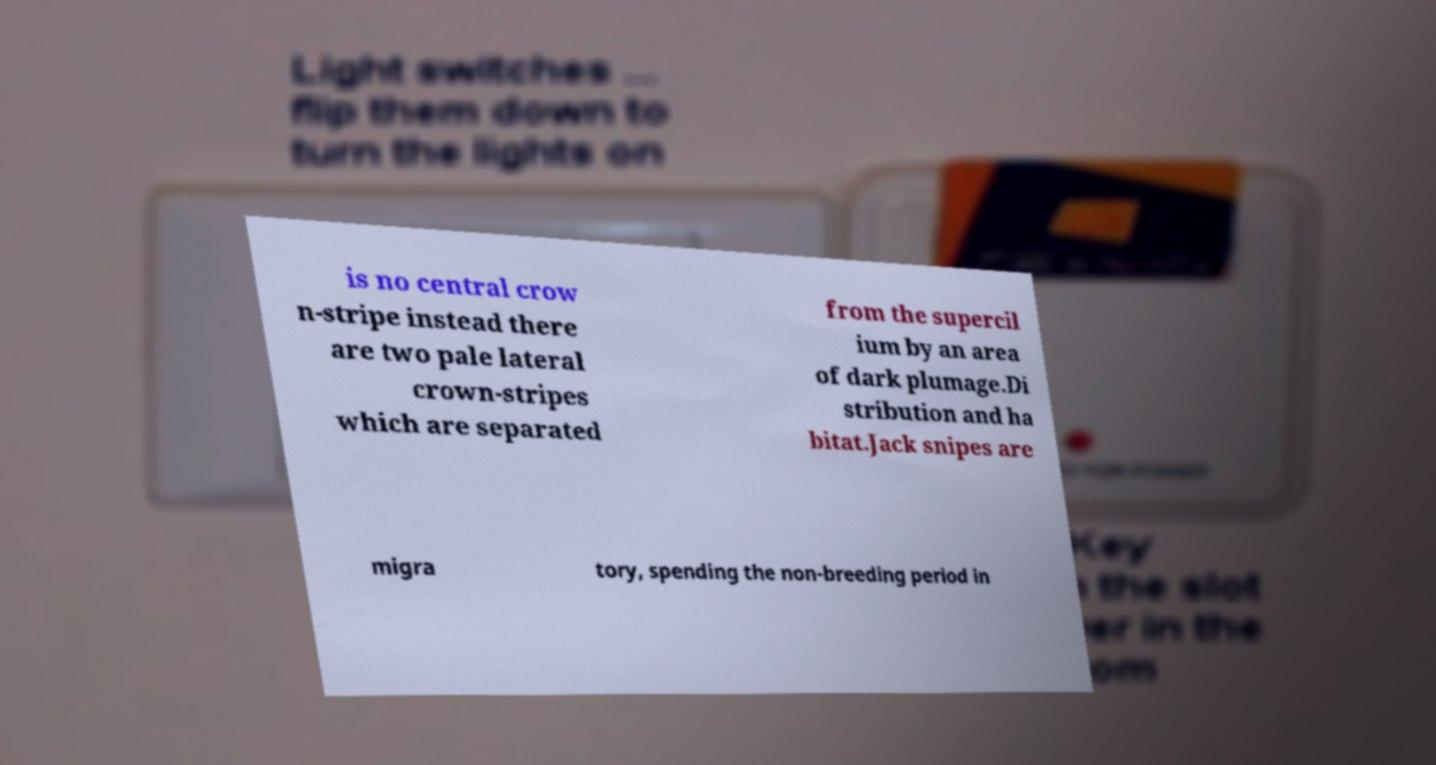Please read and relay the text visible in this image. What does it say? is no central crow n-stripe instead there are two pale lateral crown-stripes which are separated from the supercil ium by an area of dark plumage.Di stribution and ha bitat.Jack snipes are migra tory, spending the non-breeding period in 